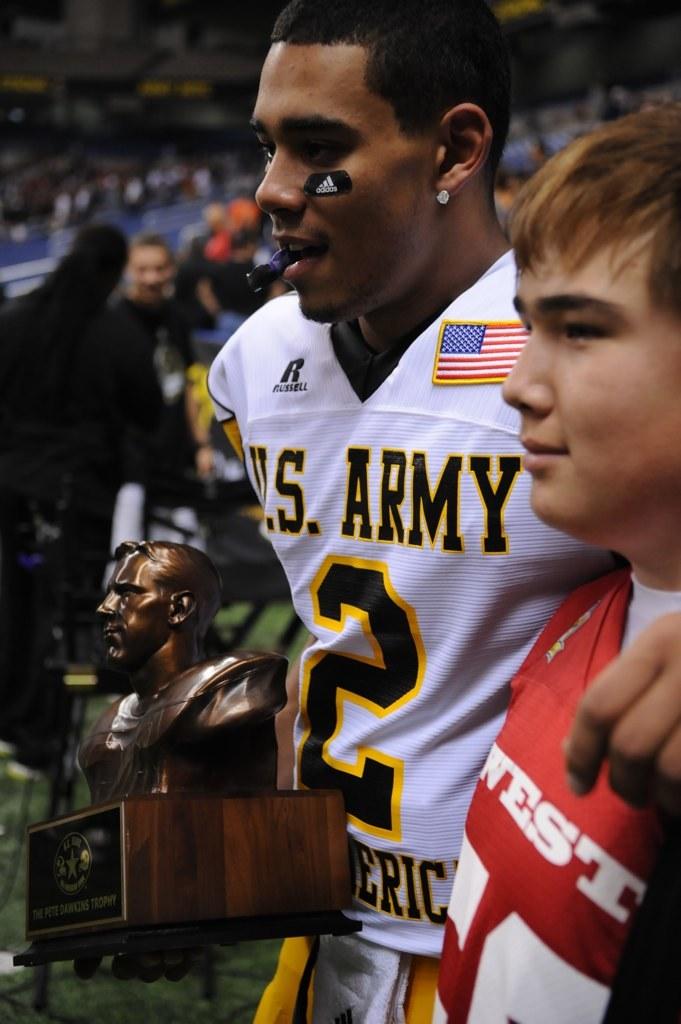What is this man jersey number?
Your response must be concise. 2. 